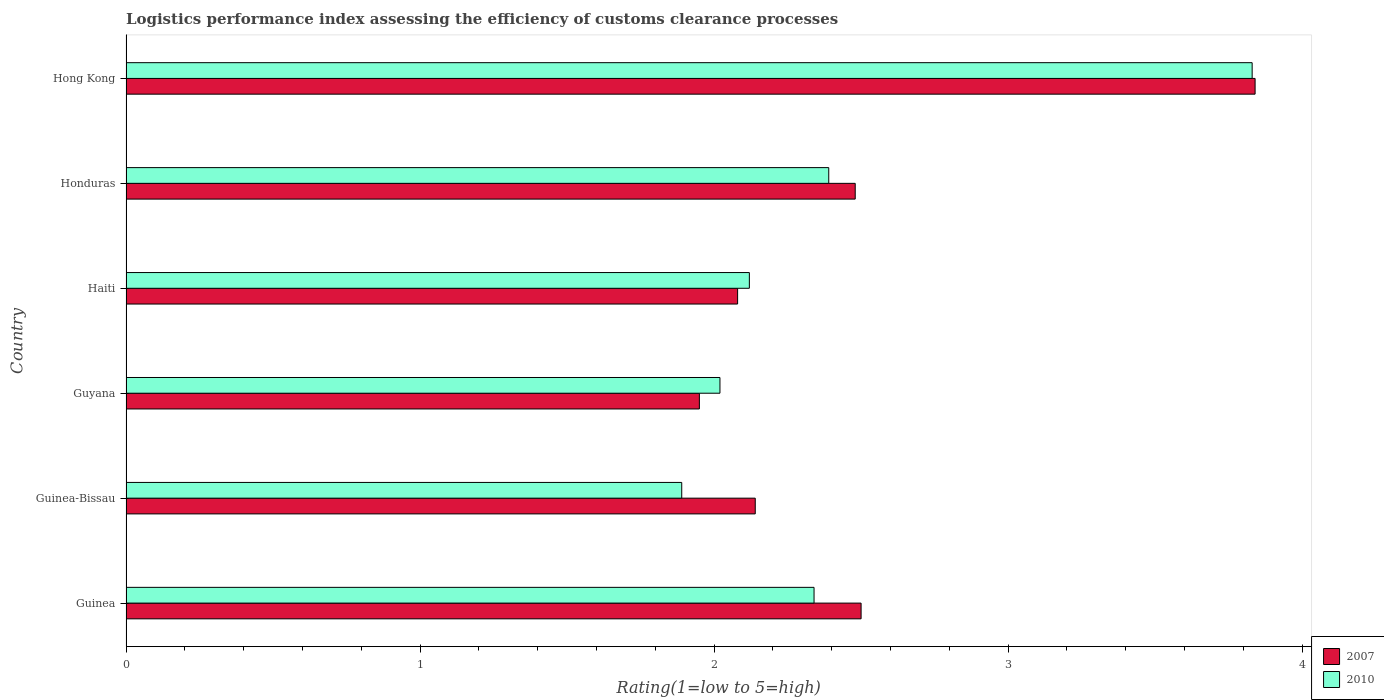How many different coloured bars are there?
Your answer should be compact. 2. How many groups of bars are there?
Offer a terse response. 6. Are the number of bars per tick equal to the number of legend labels?
Your answer should be very brief. Yes. Are the number of bars on each tick of the Y-axis equal?
Make the answer very short. Yes. How many bars are there on the 6th tick from the bottom?
Your response must be concise. 2. What is the label of the 2nd group of bars from the top?
Ensure brevity in your answer.  Honduras. In how many cases, is the number of bars for a given country not equal to the number of legend labels?
Your response must be concise. 0. What is the Logistic performance index in 2010 in Guinea?
Offer a very short reply. 2.34. Across all countries, what is the maximum Logistic performance index in 2007?
Keep it short and to the point. 3.84. Across all countries, what is the minimum Logistic performance index in 2007?
Give a very brief answer. 1.95. In which country was the Logistic performance index in 2007 maximum?
Your answer should be compact. Hong Kong. In which country was the Logistic performance index in 2010 minimum?
Your answer should be very brief. Guinea-Bissau. What is the total Logistic performance index in 2007 in the graph?
Ensure brevity in your answer.  14.99. What is the difference between the Logistic performance index in 2010 in Guinea and that in Haiti?
Your response must be concise. 0.22. What is the difference between the Logistic performance index in 2007 in Honduras and the Logistic performance index in 2010 in Guyana?
Your answer should be very brief. 0.46. What is the average Logistic performance index in 2010 per country?
Provide a succinct answer. 2.43. What is the difference between the Logistic performance index in 2007 and Logistic performance index in 2010 in Guyana?
Your answer should be very brief. -0.07. What is the ratio of the Logistic performance index in 2007 in Guinea to that in Haiti?
Offer a very short reply. 1.2. Is the Logistic performance index in 2007 in Guinea-Bissau less than that in Honduras?
Offer a very short reply. Yes. What is the difference between the highest and the second highest Logistic performance index in 2007?
Offer a terse response. 1.34. What is the difference between the highest and the lowest Logistic performance index in 2010?
Offer a terse response. 1.94. Is the sum of the Logistic performance index in 2007 in Guinea and Honduras greater than the maximum Logistic performance index in 2010 across all countries?
Your answer should be compact. Yes. What does the 2nd bar from the top in Guinea-Bissau represents?
Your answer should be compact. 2007. What does the 1st bar from the bottom in Haiti represents?
Offer a very short reply. 2007. How many bars are there?
Provide a succinct answer. 12. How many countries are there in the graph?
Give a very brief answer. 6. What is the difference between two consecutive major ticks on the X-axis?
Offer a very short reply. 1. Does the graph contain any zero values?
Your answer should be very brief. No. Does the graph contain grids?
Your answer should be compact. No. Where does the legend appear in the graph?
Your response must be concise. Bottom right. What is the title of the graph?
Your answer should be compact. Logistics performance index assessing the efficiency of customs clearance processes. Does "1970" appear as one of the legend labels in the graph?
Provide a short and direct response. No. What is the label or title of the X-axis?
Make the answer very short. Rating(1=low to 5=high). What is the Rating(1=low to 5=high) in 2007 in Guinea?
Provide a succinct answer. 2.5. What is the Rating(1=low to 5=high) in 2010 in Guinea?
Your answer should be very brief. 2.34. What is the Rating(1=low to 5=high) in 2007 in Guinea-Bissau?
Provide a short and direct response. 2.14. What is the Rating(1=low to 5=high) of 2010 in Guinea-Bissau?
Your answer should be compact. 1.89. What is the Rating(1=low to 5=high) of 2007 in Guyana?
Your answer should be compact. 1.95. What is the Rating(1=low to 5=high) of 2010 in Guyana?
Offer a very short reply. 2.02. What is the Rating(1=low to 5=high) of 2007 in Haiti?
Offer a very short reply. 2.08. What is the Rating(1=low to 5=high) in 2010 in Haiti?
Your answer should be very brief. 2.12. What is the Rating(1=low to 5=high) of 2007 in Honduras?
Your answer should be compact. 2.48. What is the Rating(1=low to 5=high) of 2010 in Honduras?
Make the answer very short. 2.39. What is the Rating(1=low to 5=high) of 2007 in Hong Kong?
Provide a succinct answer. 3.84. What is the Rating(1=low to 5=high) of 2010 in Hong Kong?
Ensure brevity in your answer.  3.83. Across all countries, what is the maximum Rating(1=low to 5=high) of 2007?
Your answer should be compact. 3.84. Across all countries, what is the maximum Rating(1=low to 5=high) in 2010?
Ensure brevity in your answer.  3.83. Across all countries, what is the minimum Rating(1=low to 5=high) of 2007?
Make the answer very short. 1.95. Across all countries, what is the minimum Rating(1=low to 5=high) in 2010?
Provide a succinct answer. 1.89. What is the total Rating(1=low to 5=high) in 2007 in the graph?
Give a very brief answer. 14.99. What is the total Rating(1=low to 5=high) in 2010 in the graph?
Provide a short and direct response. 14.59. What is the difference between the Rating(1=low to 5=high) in 2007 in Guinea and that in Guinea-Bissau?
Provide a short and direct response. 0.36. What is the difference between the Rating(1=low to 5=high) of 2010 in Guinea and that in Guinea-Bissau?
Offer a terse response. 0.45. What is the difference between the Rating(1=low to 5=high) in 2007 in Guinea and that in Guyana?
Keep it short and to the point. 0.55. What is the difference between the Rating(1=low to 5=high) of 2010 in Guinea and that in Guyana?
Offer a very short reply. 0.32. What is the difference between the Rating(1=low to 5=high) of 2007 in Guinea and that in Haiti?
Your answer should be very brief. 0.42. What is the difference between the Rating(1=low to 5=high) in 2010 in Guinea and that in Haiti?
Provide a short and direct response. 0.22. What is the difference between the Rating(1=low to 5=high) of 2007 in Guinea and that in Honduras?
Keep it short and to the point. 0.02. What is the difference between the Rating(1=low to 5=high) of 2007 in Guinea and that in Hong Kong?
Your answer should be very brief. -1.34. What is the difference between the Rating(1=low to 5=high) in 2010 in Guinea and that in Hong Kong?
Provide a short and direct response. -1.49. What is the difference between the Rating(1=low to 5=high) of 2007 in Guinea-Bissau and that in Guyana?
Offer a very short reply. 0.19. What is the difference between the Rating(1=low to 5=high) in 2010 in Guinea-Bissau and that in Guyana?
Your answer should be very brief. -0.13. What is the difference between the Rating(1=low to 5=high) in 2010 in Guinea-Bissau and that in Haiti?
Your answer should be very brief. -0.23. What is the difference between the Rating(1=low to 5=high) of 2007 in Guinea-Bissau and that in Honduras?
Ensure brevity in your answer.  -0.34. What is the difference between the Rating(1=low to 5=high) of 2010 in Guinea-Bissau and that in Honduras?
Make the answer very short. -0.5. What is the difference between the Rating(1=low to 5=high) of 2010 in Guinea-Bissau and that in Hong Kong?
Offer a terse response. -1.94. What is the difference between the Rating(1=low to 5=high) in 2007 in Guyana and that in Haiti?
Provide a succinct answer. -0.13. What is the difference between the Rating(1=low to 5=high) of 2010 in Guyana and that in Haiti?
Keep it short and to the point. -0.1. What is the difference between the Rating(1=low to 5=high) of 2007 in Guyana and that in Honduras?
Provide a succinct answer. -0.53. What is the difference between the Rating(1=low to 5=high) in 2010 in Guyana and that in Honduras?
Provide a succinct answer. -0.37. What is the difference between the Rating(1=low to 5=high) in 2007 in Guyana and that in Hong Kong?
Give a very brief answer. -1.89. What is the difference between the Rating(1=low to 5=high) of 2010 in Guyana and that in Hong Kong?
Make the answer very short. -1.81. What is the difference between the Rating(1=low to 5=high) of 2007 in Haiti and that in Honduras?
Offer a terse response. -0.4. What is the difference between the Rating(1=low to 5=high) of 2010 in Haiti and that in Honduras?
Ensure brevity in your answer.  -0.27. What is the difference between the Rating(1=low to 5=high) of 2007 in Haiti and that in Hong Kong?
Your answer should be compact. -1.76. What is the difference between the Rating(1=low to 5=high) of 2010 in Haiti and that in Hong Kong?
Make the answer very short. -1.71. What is the difference between the Rating(1=low to 5=high) of 2007 in Honduras and that in Hong Kong?
Make the answer very short. -1.36. What is the difference between the Rating(1=low to 5=high) in 2010 in Honduras and that in Hong Kong?
Give a very brief answer. -1.44. What is the difference between the Rating(1=low to 5=high) in 2007 in Guinea and the Rating(1=low to 5=high) in 2010 in Guinea-Bissau?
Offer a terse response. 0.61. What is the difference between the Rating(1=low to 5=high) in 2007 in Guinea and the Rating(1=low to 5=high) in 2010 in Guyana?
Provide a succinct answer. 0.48. What is the difference between the Rating(1=low to 5=high) of 2007 in Guinea and the Rating(1=low to 5=high) of 2010 in Haiti?
Offer a very short reply. 0.38. What is the difference between the Rating(1=low to 5=high) in 2007 in Guinea and the Rating(1=low to 5=high) in 2010 in Honduras?
Provide a succinct answer. 0.11. What is the difference between the Rating(1=low to 5=high) of 2007 in Guinea and the Rating(1=low to 5=high) of 2010 in Hong Kong?
Your answer should be compact. -1.33. What is the difference between the Rating(1=low to 5=high) in 2007 in Guinea-Bissau and the Rating(1=low to 5=high) in 2010 in Guyana?
Provide a succinct answer. 0.12. What is the difference between the Rating(1=low to 5=high) in 2007 in Guinea-Bissau and the Rating(1=low to 5=high) in 2010 in Honduras?
Provide a succinct answer. -0.25. What is the difference between the Rating(1=low to 5=high) in 2007 in Guinea-Bissau and the Rating(1=low to 5=high) in 2010 in Hong Kong?
Your answer should be very brief. -1.69. What is the difference between the Rating(1=low to 5=high) of 2007 in Guyana and the Rating(1=low to 5=high) of 2010 in Haiti?
Provide a succinct answer. -0.17. What is the difference between the Rating(1=low to 5=high) of 2007 in Guyana and the Rating(1=low to 5=high) of 2010 in Honduras?
Provide a succinct answer. -0.44. What is the difference between the Rating(1=low to 5=high) in 2007 in Guyana and the Rating(1=low to 5=high) in 2010 in Hong Kong?
Your answer should be very brief. -1.88. What is the difference between the Rating(1=low to 5=high) in 2007 in Haiti and the Rating(1=low to 5=high) in 2010 in Honduras?
Give a very brief answer. -0.31. What is the difference between the Rating(1=low to 5=high) in 2007 in Haiti and the Rating(1=low to 5=high) in 2010 in Hong Kong?
Make the answer very short. -1.75. What is the difference between the Rating(1=low to 5=high) in 2007 in Honduras and the Rating(1=low to 5=high) in 2010 in Hong Kong?
Make the answer very short. -1.35. What is the average Rating(1=low to 5=high) of 2007 per country?
Make the answer very short. 2.5. What is the average Rating(1=low to 5=high) of 2010 per country?
Provide a succinct answer. 2.43. What is the difference between the Rating(1=low to 5=high) in 2007 and Rating(1=low to 5=high) in 2010 in Guinea?
Offer a terse response. 0.16. What is the difference between the Rating(1=low to 5=high) of 2007 and Rating(1=low to 5=high) of 2010 in Guyana?
Offer a very short reply. -0.07. What is the difference between the Rating(1=low to 5=high) in 2007 and Rating(1=low to 5=high) in 2010 in Haiti?
Your answer should be very brief. -0.04. What is the difference between the Rating(1=low to 5=high) of 2007 and Rating(1=low to 5=high) of 2010 in Honduras?
Ensure brevity in your answer.  0.09. What is the difference between the Rating(1=low to 5=high) of 2007 and Rating(1=low to 5=high) of 2010 in Hong Kong?
Offer a terse response. 0.01. What is the ratio of the Rating(1=low to 5=high) in 2007 in Guinea to that in Guinea-Bissau?
Ensure brevity in your answer.  1.17. What is the ratio of the Rating(1=low to 5=high) in 2010 in Guinea to that in Guinea-Bissau?
Your answer should be very brief. 1.24. What is the ratio of the Rating(1=low to 5=high) in 2007 in Guinea to that in Guyana?
Provide a short and direct response. 1.28. What is the ratio of the Rating(1=low to 5=high) in 2010 in Guinea to that in Guyana?
Ensure brevity in your answer.  1.16. What is the ratio of the Rating(1=low to 5=high) in 2007 in Guinea to that in Haiti?
Provide a short and direct response. 1.2. What is the ratio of the Rating(1=low to 5=high) of 2010 in Guinea to that in Haiti?
Your answer should be very brief. 1.1. What is the ratio of the Rating(1=low to 5=high) in 2007 in Guinea to that in Honduras?
Provide a short and direct response. 1.01. What is the ratio of the Rating(1=low to 5=high) of 2010 in Guinea to that in Honduras?
Keep it short and to the point. 0.98. What is the ratio of the Rating(1=low to 5=high) in 2007 in Guinea to that in Hong Kong?
Make the answer very short. 0.65. What is the ratio of the Rating(1=low to 5=high) of 2010 in Guinea to that in Hong Kong?
Keep it short and to the point. 0.61. What is the ratio of the Rating(1=low to 5=high) in 2007 in Guinea-Bissau to that in Guyana?
Make the answer very short. 1.1. What is the ratio of the Rating(1=low to 5=high) in 2010 in Guinea-Bissau to that in Guyana?
Ensure brevity in your answer.  0.94. What is the ratio of the Rating(1=low to 5=high) of 2007 in Guinea-Bissau to that in Haiti?
Your response must be concise. 1.03. What is the ratio of the Rating(1=low to 5=high) of 2010 in Guinea-Bissau to that in Haiti?
Give a very brief answer. 0.89. What is the ratio of the Rating(1=low to 5=high) in 2007 in Guinea-Bissau to that in Honduras?
Give a very brief answer. 0.86. What is the ratio of the Rating(1=low to 5=high) in 2010 in Guinea-Bissau to that in Honduras?
Your response must be concise. 0.79. What is the ratio of the Rating(1=low to 5=high) of 2007 in Guinea-Bissau to that in Hong Kong?
Give a very brief answer. 0.56. What is the ratio of the Rating(1=low to 5=high) of 2010 in Guinea-Bissau to that in Hong Kong?
Make the answer very short. 0.49. What is the ratio of the Rating(1=low to 5=high) of 2010 in Guyana to that in Haiti?
Ensure brevity in your answer.  0.95. What is the ratio of the Rating(1=low to 5=high) of 2007 in Guyana to that in Honduras?
Your response must be concise. 0.79. What is the ratio of the Rating(1=low to 5=high) of 2010 in Guyana to that in Honduras?
Keep it short and to the point. 0.85. What is the ratio of the Rating(1=low to 5=high) of 2007 in Guyana to that in Hong Kong?
Your answer should be very brief. 0.51. What is the ratio of the Rating(1=low to 5=high) of 2010 in Guyana to that in Hong Kong?
Offer a very short reply. 0.53. What is the ratio of the Rating(1=low to 5=high) in 2007 in Haiti to that in Honduras?
Keep it short and to the point. 0.84. What is the ratio of the Rating(1=low to 5=high) of 2010 in Haiti to that in Honduras?
Provide a succinct answer. 0.89. What is the ratio of the Rating(1=low to 5=high) in 2007 in Haiti to that in Hong Kong?
Keep it short and to the point. 0.54. What is the ratio of the Rating(1=low to 5=high) in 2010 in Haiti to that in Hong Kong?
Keep it short and to the point. 0.55. What is the ratio of the Rating(1=low to 5=high) of 2007 in Honduras to that in Hong Kong?
Your answer should be very brief. 0.65. What is the ratio of the Rating(1=low to 5=high) in 2010 in Honduras to that in Hong Kong?
Keep it short and to the point. 0.62. What is the difference between the highest and the second highest Rating(1=low to 5=high) in 2007?
Your answer should be compact. 1.34. What is the difference between the highest and the second highest Rating(1=low to 5=high) of 2010?
Offer a terse response. 1.44. What is the difference between the highest and the lowest Rating(1=low to 5=high) in 2007?
Your response must be concise. 1.89. What is the difference between the highest and the lowest Rating(1=low to 5=high) in 2010?
Your answer should be very brief. 1.94. 